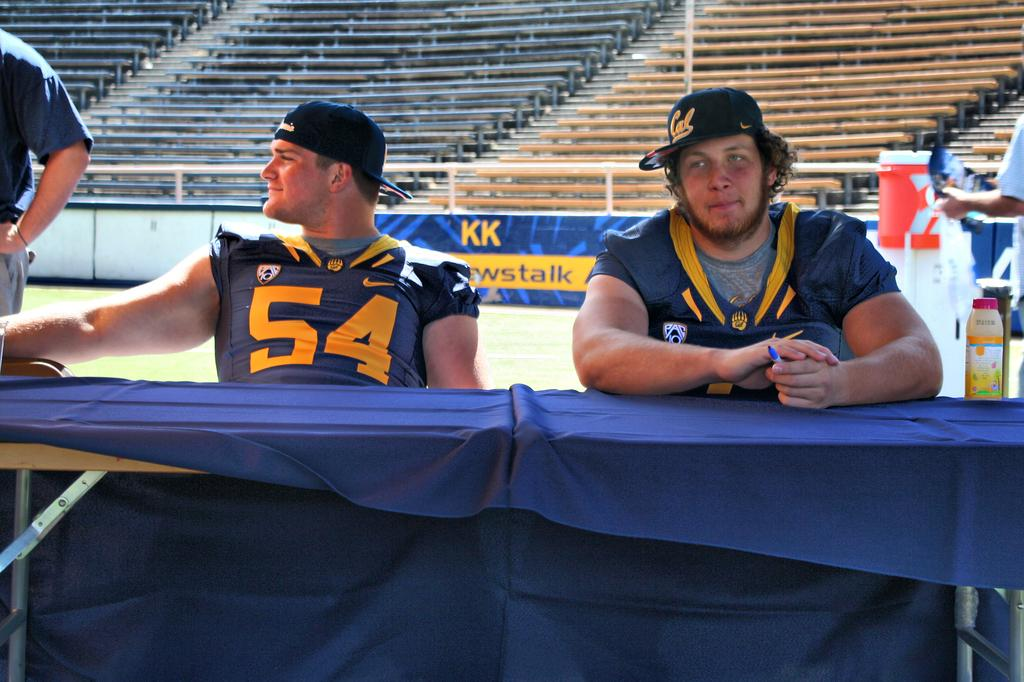<image>
Provide a brief description of the given image. Two sport players are sitting at a table and one of the jerseys reads "54". 